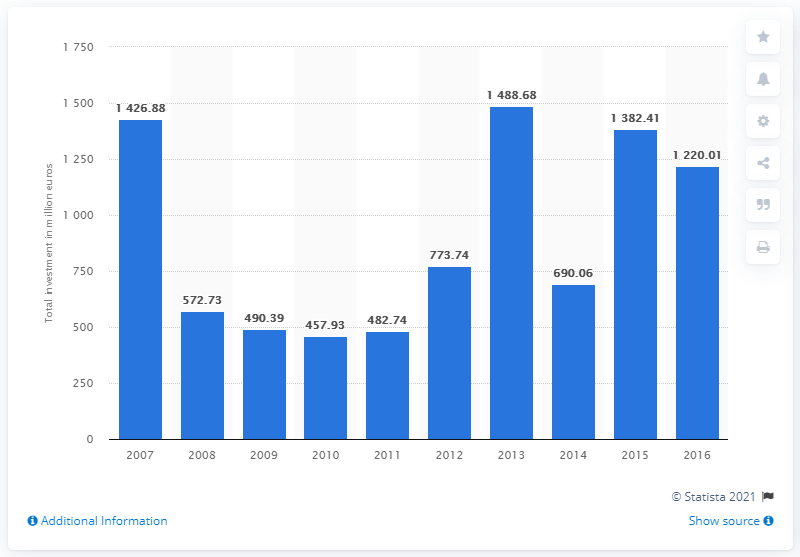Identify some key points in this picture. According to data from 2016, the value of private equity investments was 1220.01. The average total investment from 2013 to 2016 was 1195.29. The total investment in 2014 was 690.06. The largest total value of private equity investments was found in 2013. 